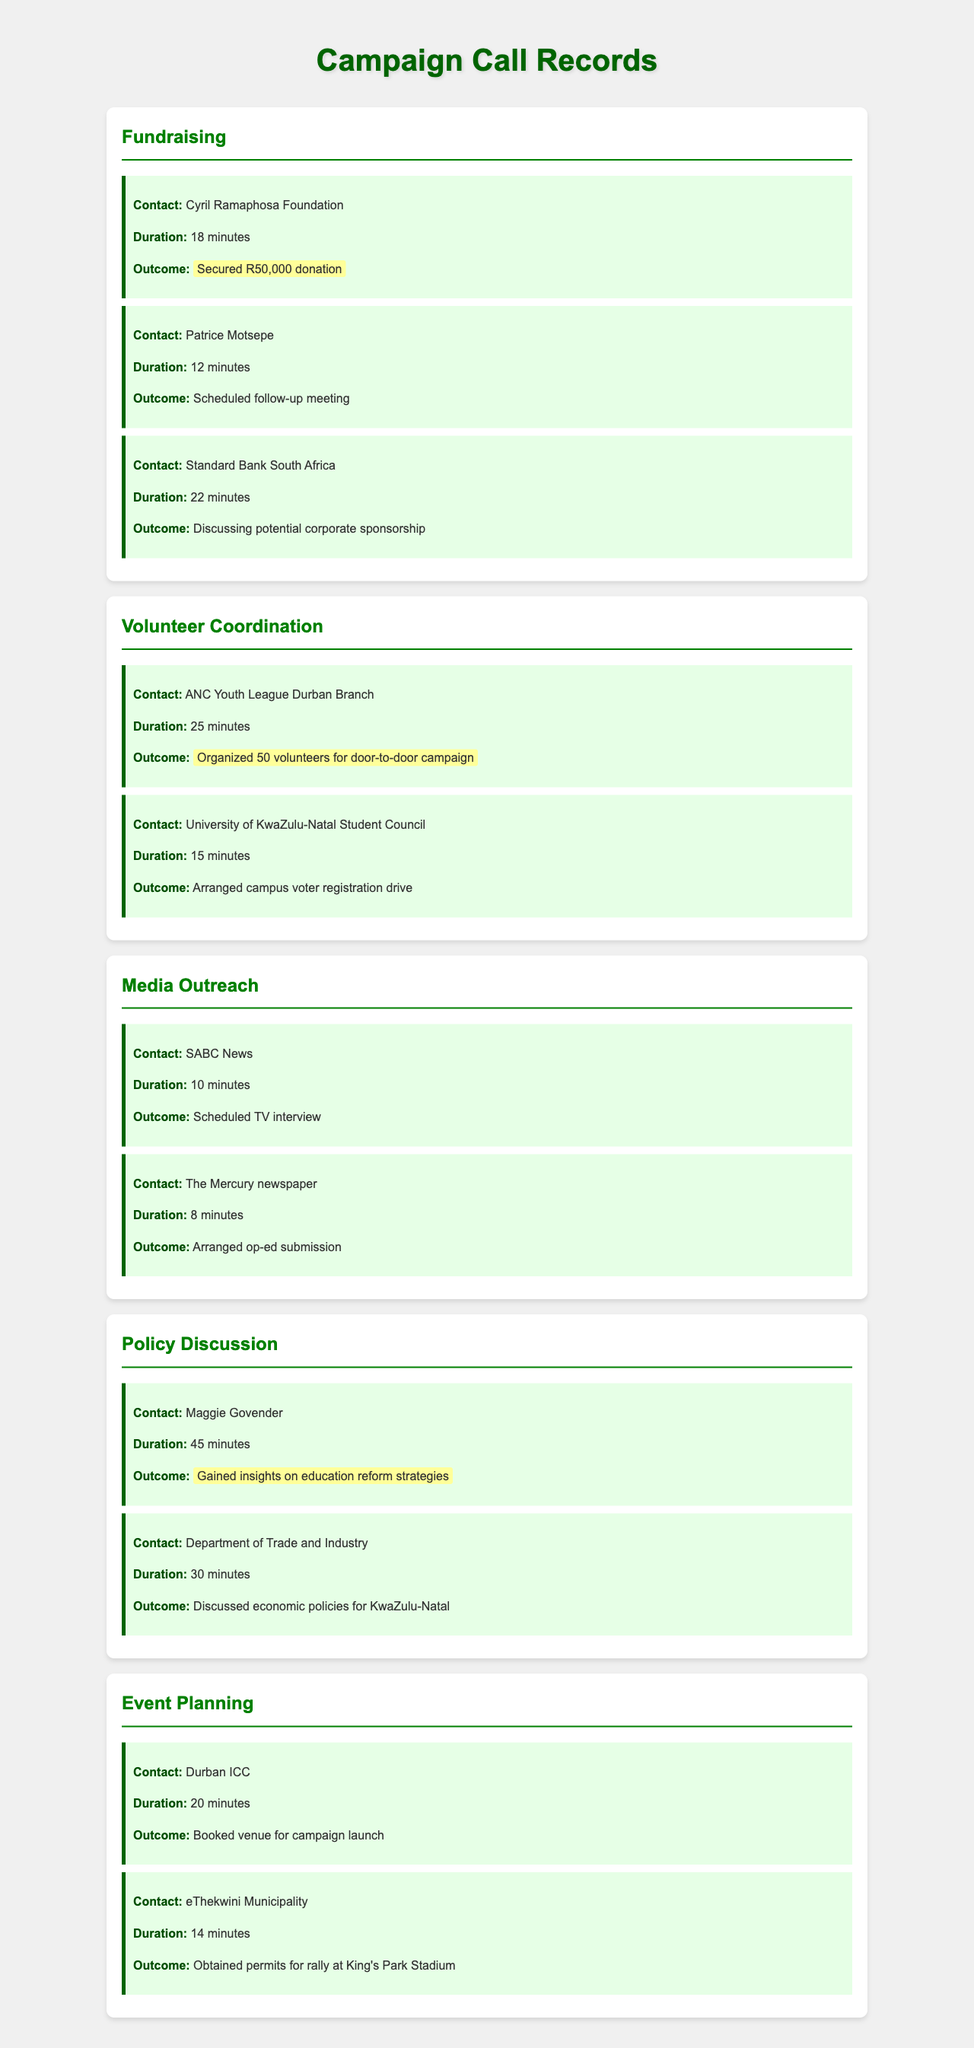What was the outcome of the call with Cyril Ramaphosa Foundation? The outcome is specifically noted as the secured donation from this contact.
Answer: Secured R50,000 donation How long was the call with the ANC Youth League Durban Branch? The duration of this call is provided, showing how long the communication lasted.
Answer: 25 minutes Who did you speak with regarding education reform strategies? This question asks for the specific contact related to policy discussion, focusing on the conversation about education reform.
Answer: Maggie Govender What did you arrange with the University of KwaZulu-Natal Student Council? This refers to the outcome of the call specifically related to volunteer coordination efforts concerning voter registration.
Answer: Arranged campus voter registration drive Which organization was contacted for corporate sponsorship discussion? This question targets the call that involved discussing potential sponsorship, requiring connection between a specific organization and purpose.
Answer: Standard Bank South Africa How many volunteers were organized for the door-to-door campaign? This question inquires about the result of the coordination efforts specifically mentioning the number of volunteers involved.
Answer: 50 volunteers What venue was booked for the campaign launch? The question specifically asks for the location mentioned in the discussion about event planning.
Answer: Durban ICC How many minutes long was the call with the Department of Trade and Industry? This question looks for the duration of a specific call related to policy discussion.
Answer: 30 minutes What was scheduled with SABC News? The outcome of the media outreach call is shown, focusing on a particular arrangement made during the call.
Answer: Scheduled TV interview 